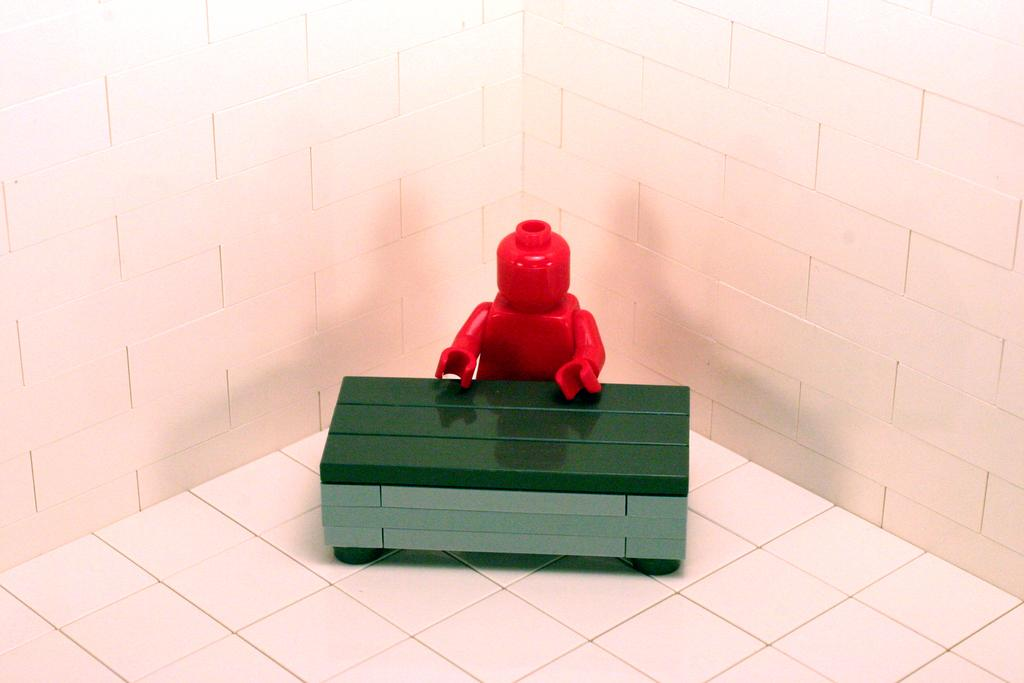What is located in the center of the image? There is a toy and a box in the center of the image. What can be seen in the background of the image? There is a wall in the background of the image. What is at the bottom of the image? There is a floor at the bottom of the image. What does the stranger's voice sound like in the image? There is no stranger or voice present in the image. 